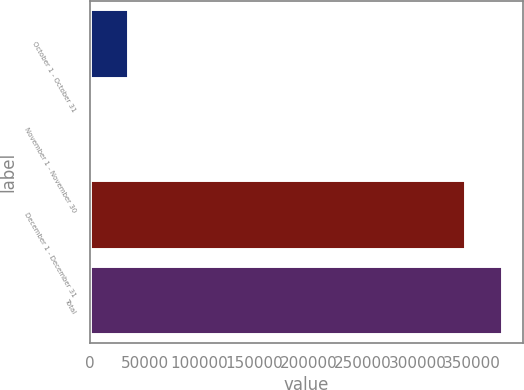<chart> <loc_0><loc_0><loc_500><loc_500><bar_chart><fcel>October 1 - October 31<fcel>November 1 - November 30<fcel>December 1 - December 31<fcel>Total<nl><fcel>34461.3<fcel>39<fcel>343187<fcel>377609<nl></chart> 